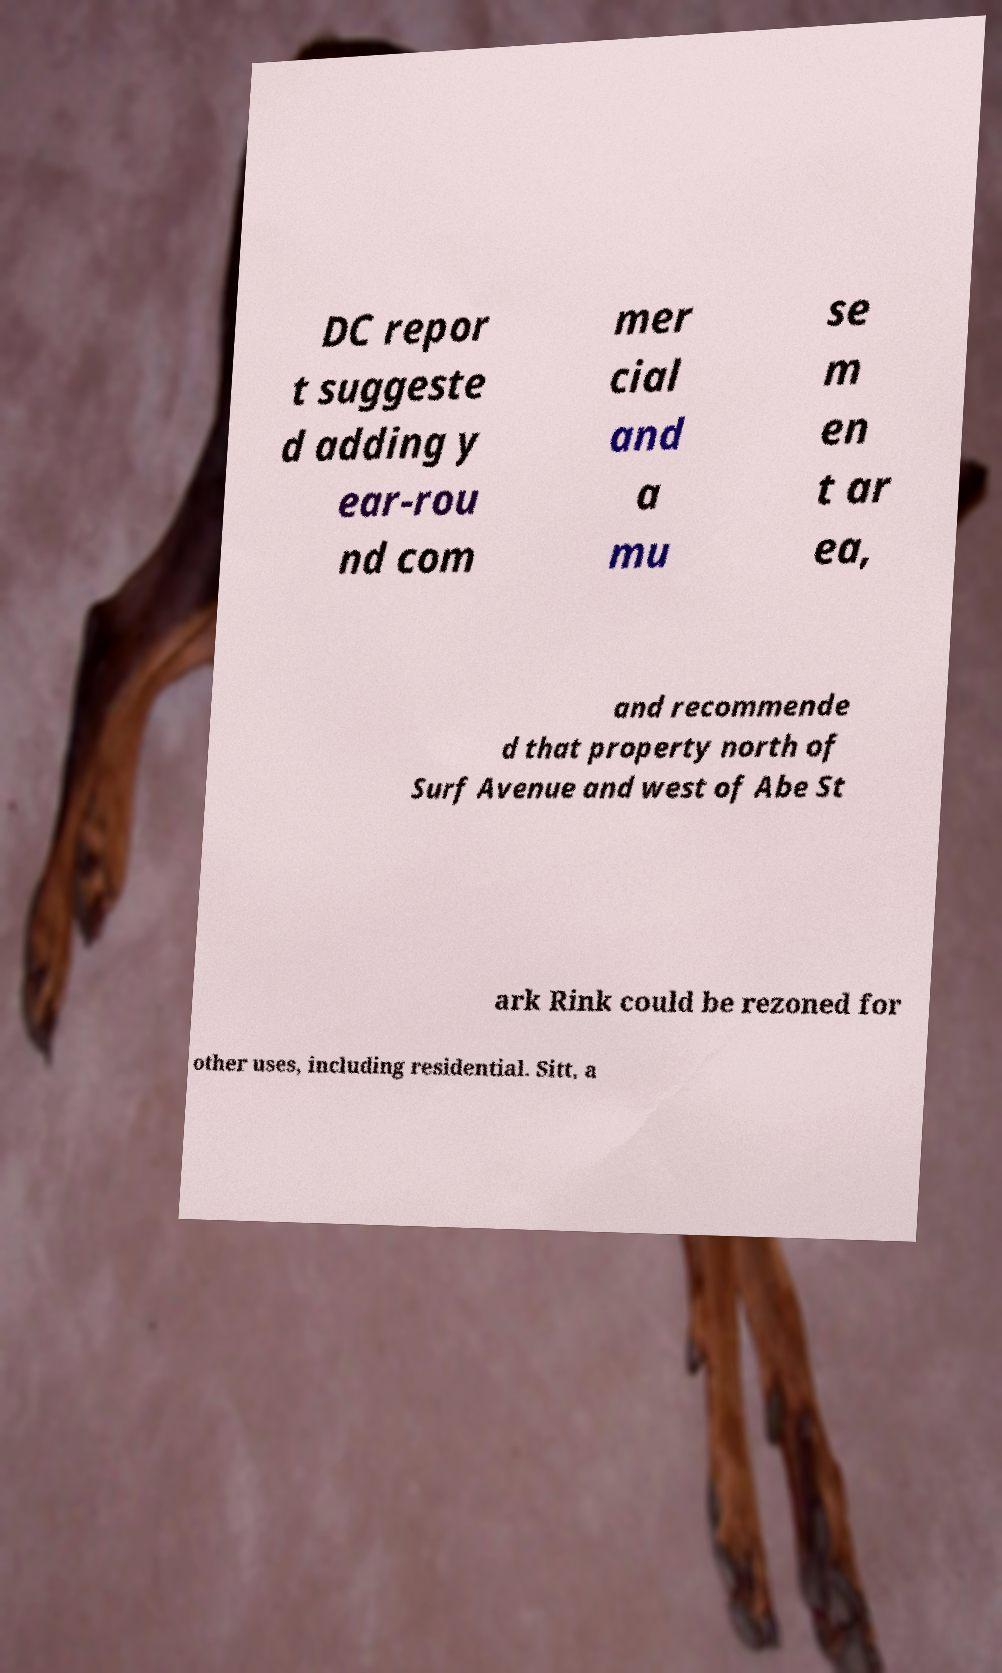Can you read and provide the text displayed in the image?This photo seems to have some interesting text. Can you extract and type it out for me? DC repor t suggeste d adding y ear-rou nd com mer cial and a mu se m en t ar ea, and recommende d that property north of Surf Avenue and west of Abe St ark Rink could be rezoned for other uses, including residential. Sitt, a 